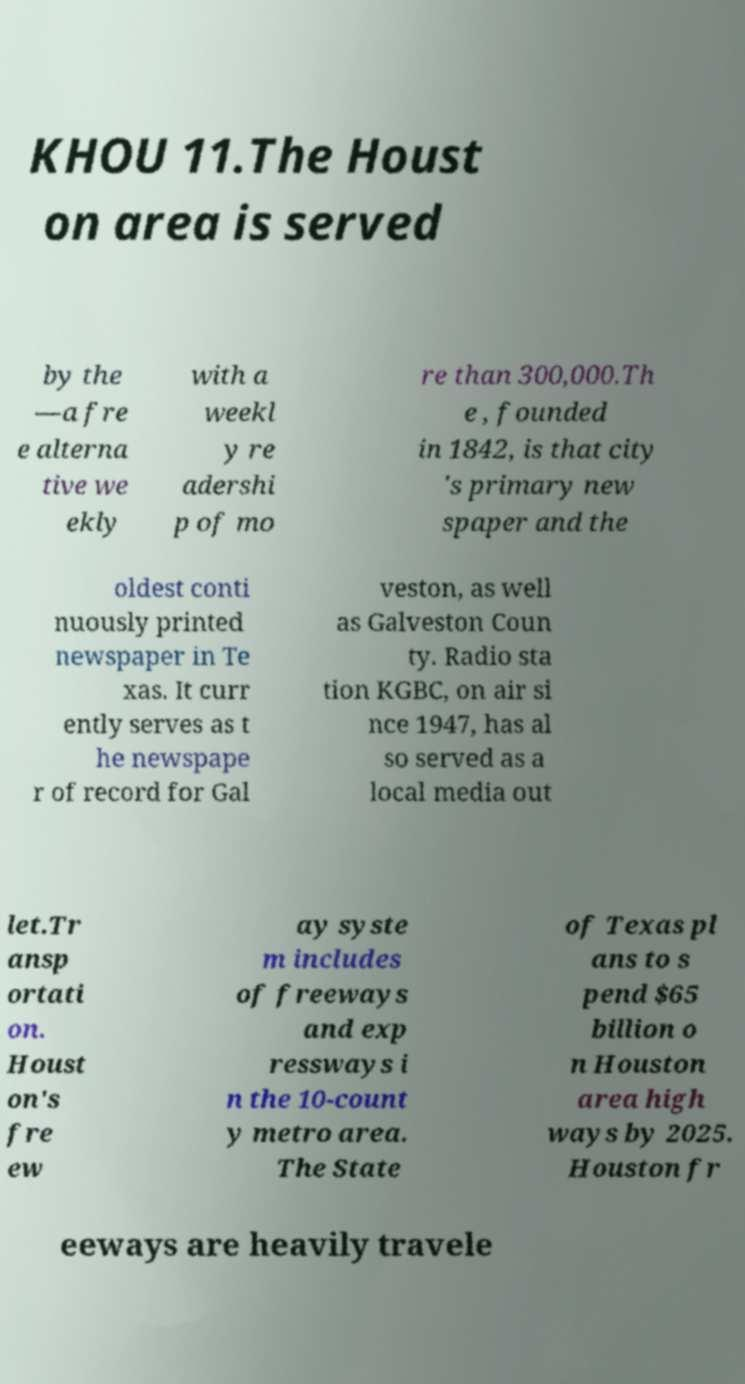What messages or text are displayed in this image? I need them in a readable, typed format. KHOU 11.The Houst on area is served by the —a fre e alterna tive we ekly with a weekl y re adershi p of mo re than 300,000.Th e , founded in 1842, is that city 's primary new spaper and the oldest conti nuously printed newspaper in Te xas. It curr ently serves as t he newspape r of record for Gal veston, as well as Galveston Coun ty. Radio sta tion KGBC, on air si nce 1947, has al so served as a local media out let.Tr ansp ortati on. Houst on's fre ew ay syste m includes of freeways and exp ressways i n the 10-count y metro area. The State of Texas pl ans to s pend $65 billion o n Houston area high ways by 2025. Houston fr eeways are heavily travele 